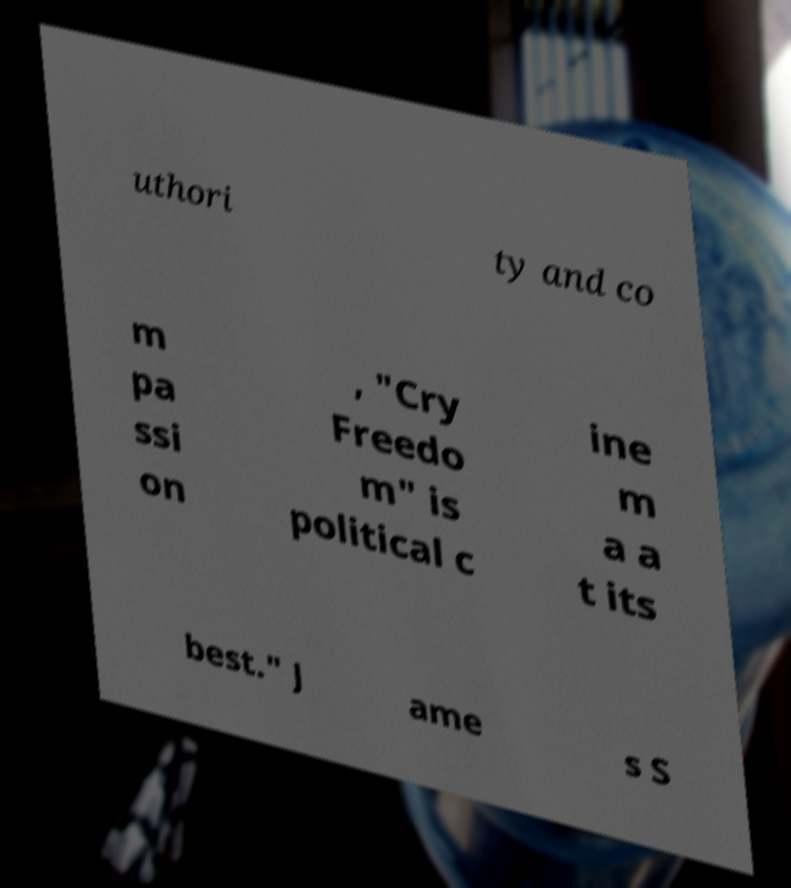Can you read and provide the text displayed in the image?This photo seems to have some interesting text. Can you extract and type it out for me? uthori ty and co m pa ssi on , "Cry Freedo m" is political c ine m a a t its best." J ame s S 